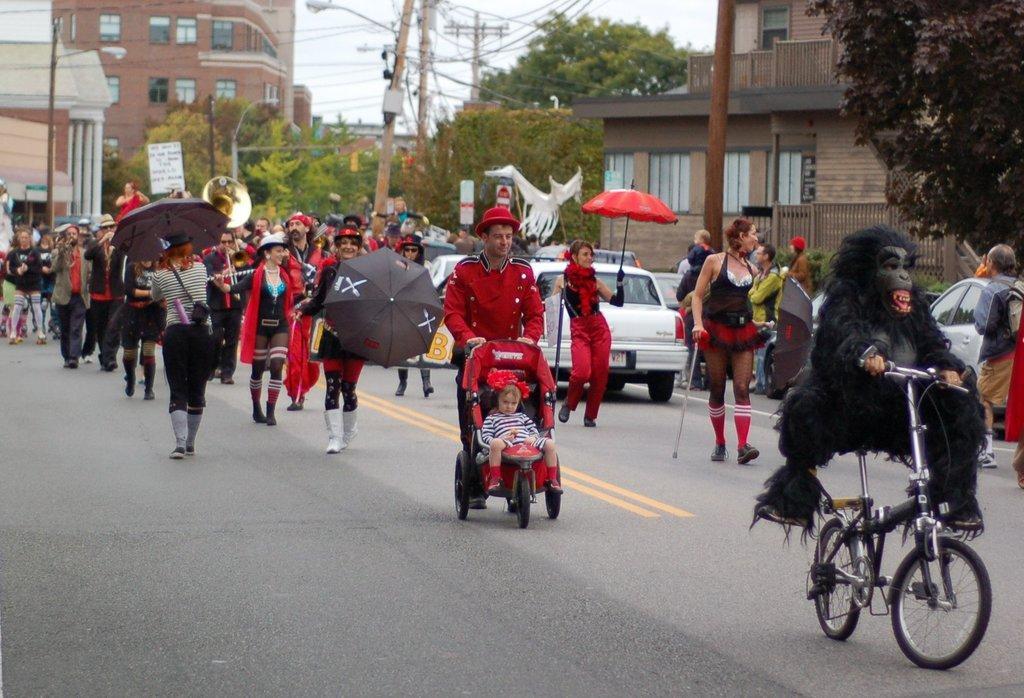How would you summarize this image in a sentence or two? In this image there are people and buildings in the left corner. There are people holding objects, there are vehicles in the foreground. There is a road at the bottom. There are trees and buildings in the background. There are buildings, trees, vehicles and people in the right corner. And there is a sky at the top. 